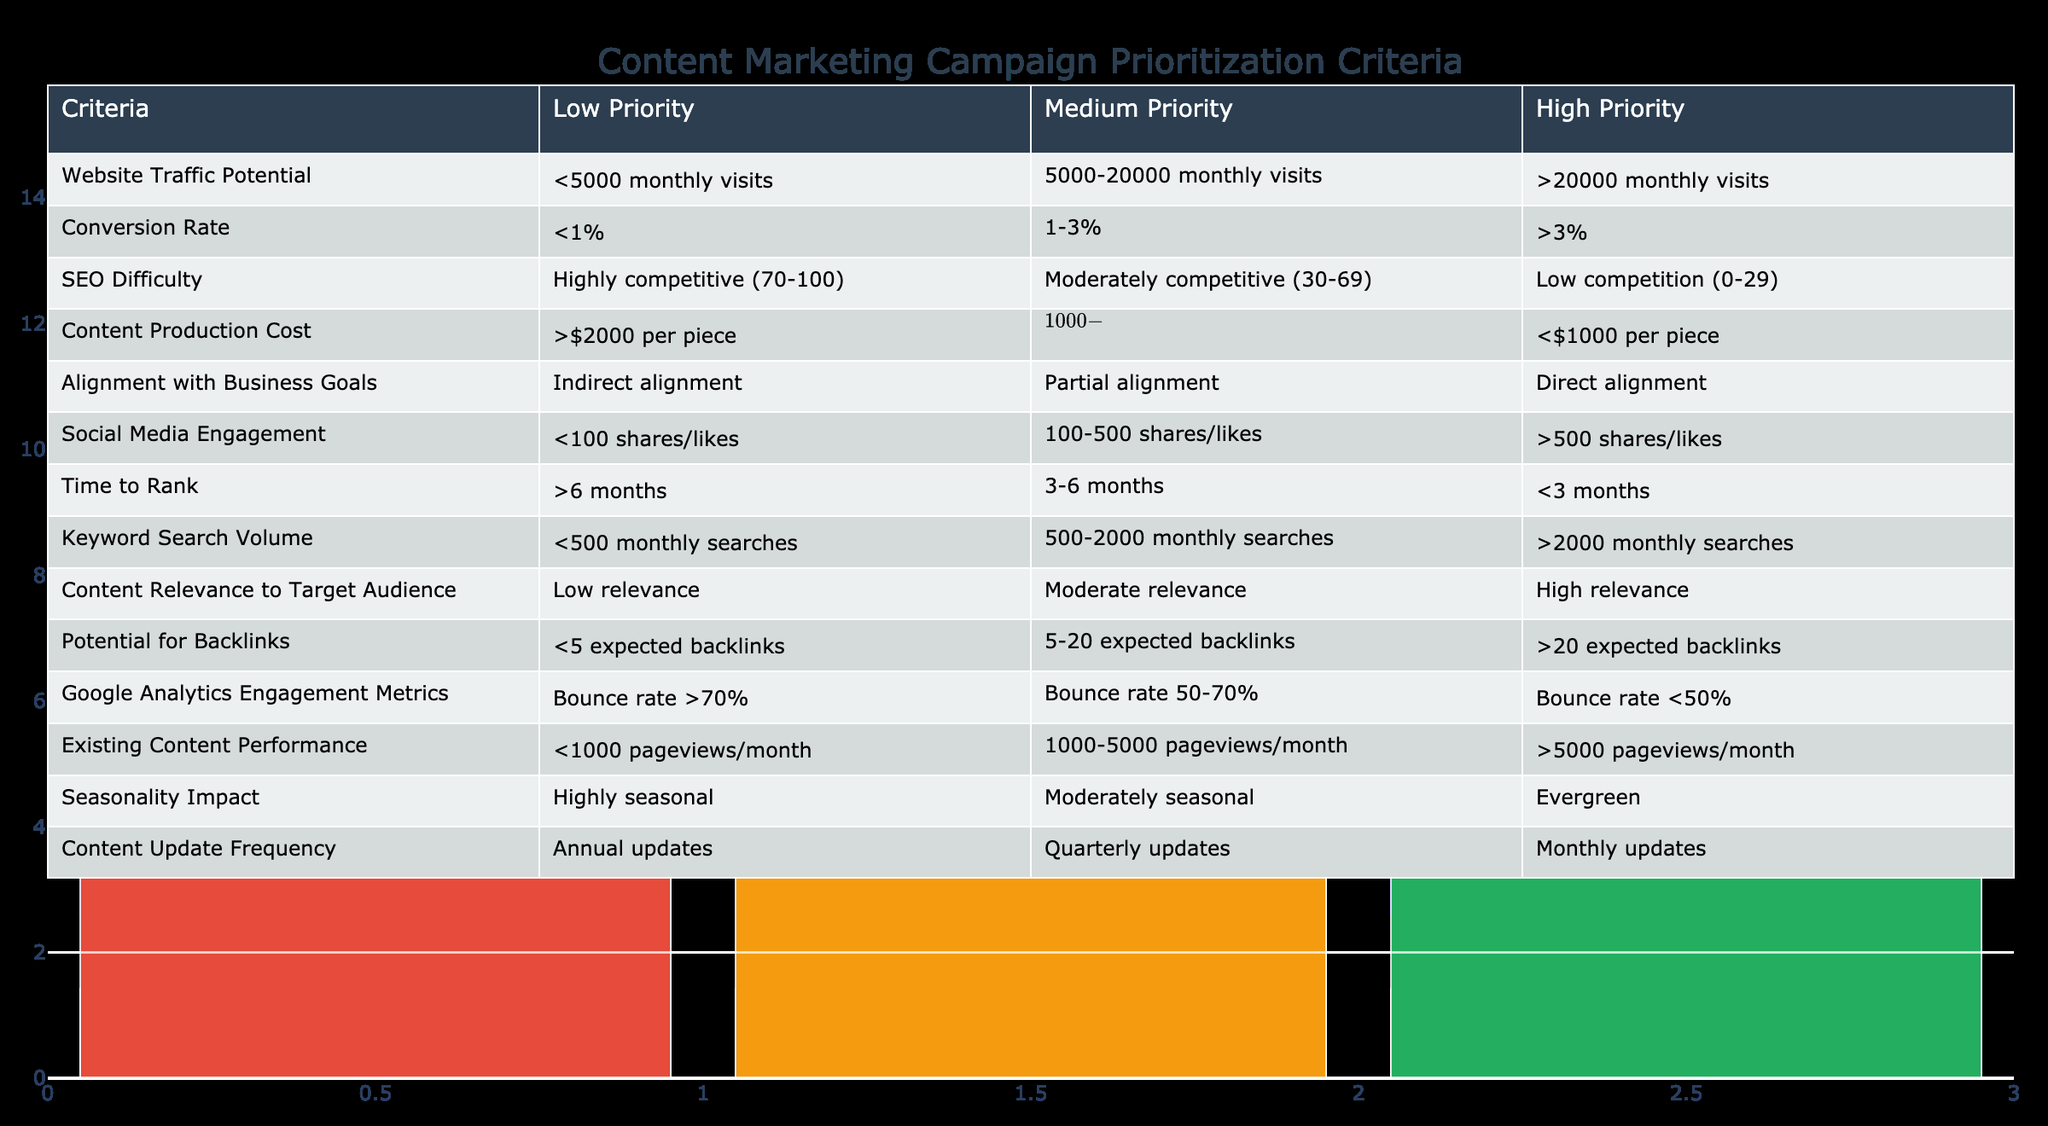What is the highest potential for backlinks in the table? The highest potential for backlinks is categorized as ">20 expected backlinks" which is listed under the "High Priority" column in the table.
Answer: >20 expected backlinks What is the conversion rate range that qualifies as "Medium Priority"? The "Medium Priority" for the conversion rate is defined as "1-3%," as indicated in the relevant cell under the medium priority column.
Answer: 1-3% Are content pieces with a production cost of less than $1000 considered high priority? Yes, content pieces with a production cost of "<$1000 per piece" are classified under the "High Priority" category in the table.
Answer: Yes Which criteria has a potential range for website traffic categorized as low priority? The low priority range for website traffic potential is defined as "<5000 monthly visits," as shown in the appropriate cell in the table.
Answer: <5000 monthly visits What is the average SEO difficulty score for high priority content? High priority content is characterized by an SEO difficulty of "Low competition (0-29)." To find the average, we can consider the range typically represented in scores, but as per the table, this specific value categorization suffices.
Answer: Low competition (0-29) What is the relationship between content relevance and the expected number of backlinks? According to the table, high relevance content is classified as "High relevance," which corresponds with a high priority for having more than ">20 expected backlinks." Thus, the relationship is direct, as highly relevant content tends to attract more backlinks.
Answer: Direct relationship How does the social media engagement level align with priority categorization? The engagement levels are clearly demarcated: low engagement indicated by "<100 shares/likes" aligns with low priority, "100-500 shares/likes" aligns with medium priority, and ">500 shares/likes" aligns with high priority—indicating an increasing priority with increasing engagement.
Answer: Increasing priority with engagement What is the time to rank criterion for high priority content? The high priority criterion for time to rank is defined as "<3 months," which indicates it is favorable for content to rank quickly in search engines.
Answer: <3 months Is it true that existing content performance of 5000-10000 pageviews/month aligns with high priority? No, existing content performance categorized as ">5000 pageviews/month" aligns with high priority, whereas the range of "1000-5000 pageviews/month" falls under medium priority.
Answer: No 